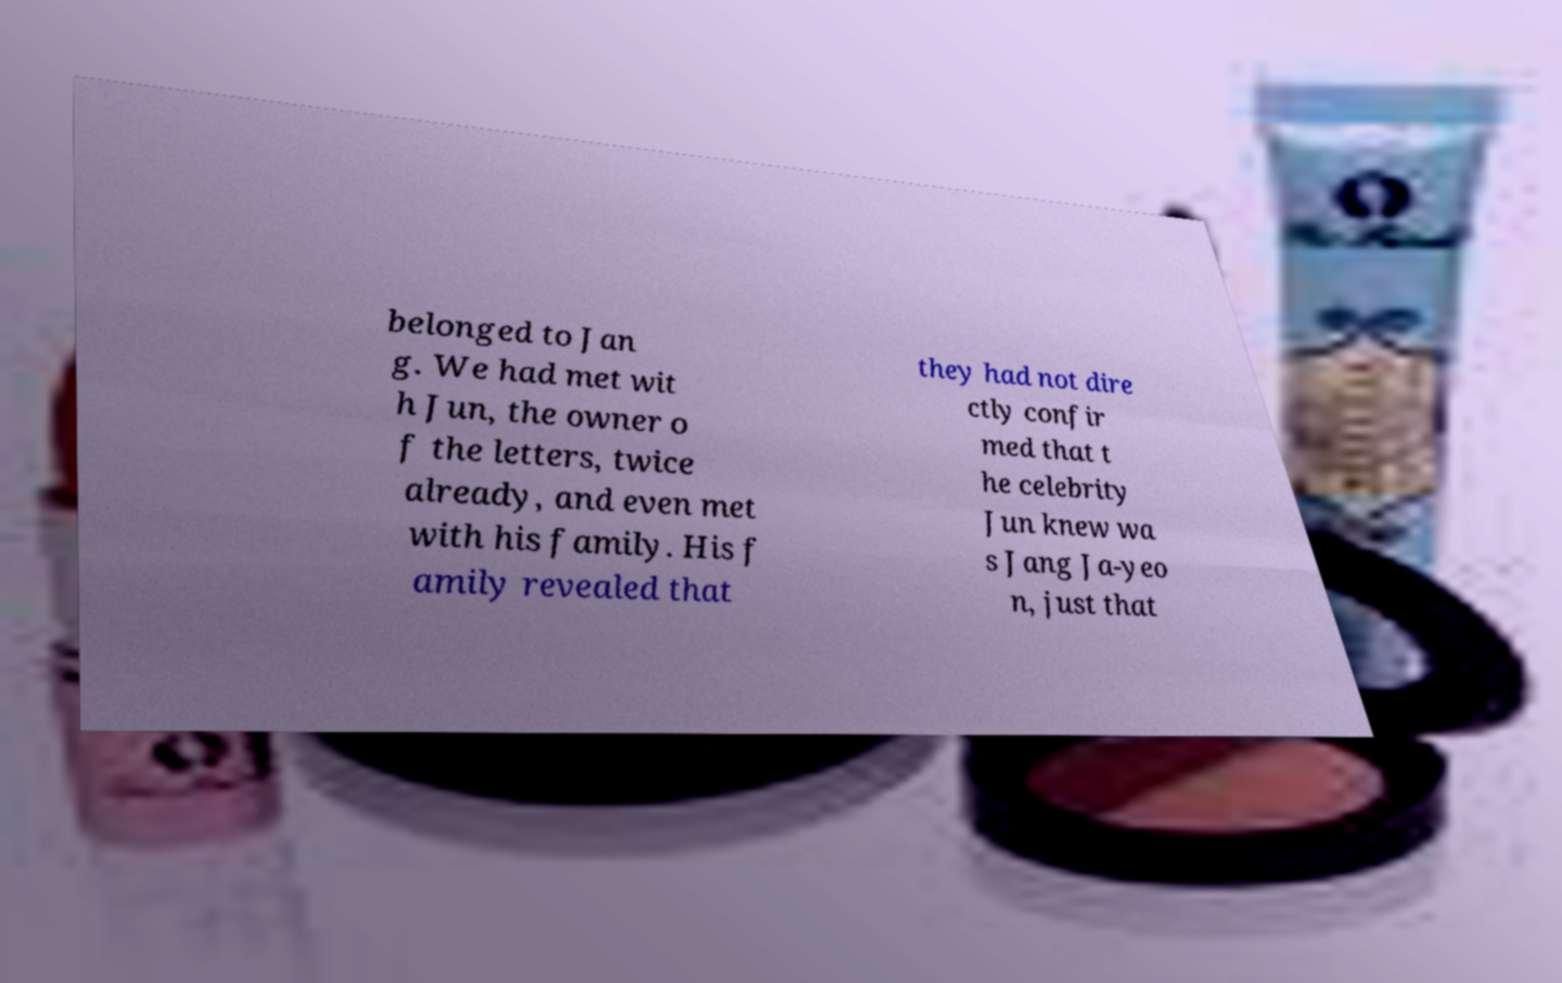I need the written content from this picture converted into text. Can you do that? belonged to Jan g. We had met wit h Jun, the owner o f the letters, twice already, and even met with his family. His f amily revealed that they had not dire ctly confir med that t he celebrity Jun knew wa s Jang Ja-yeo n, just that 